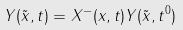<formula> <loc_0><loc_0><loc_500><loc_500>Y ( \tilde { x } , t ) = X ^ { - } ( x , t ) Y ( \tilde { x } , t ^ { 0 } )</formula> 